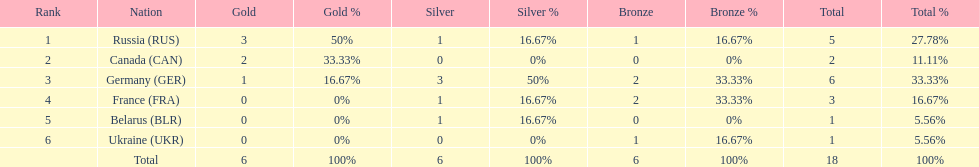Who had a larger total medal count, france or canada? France. 